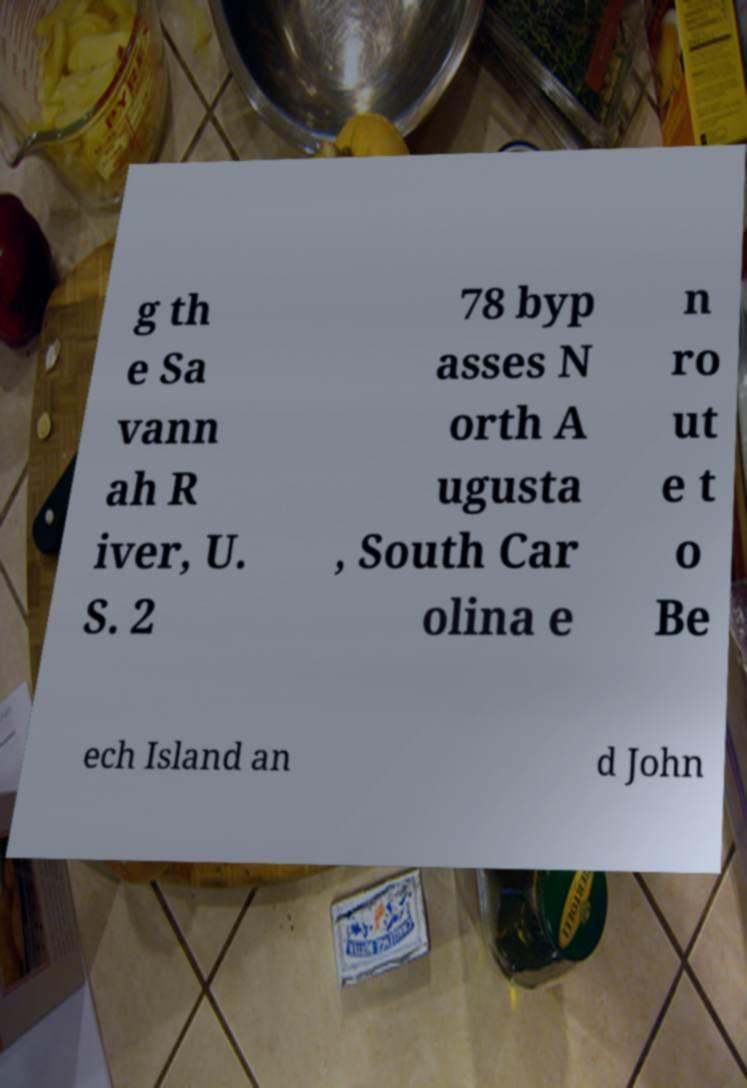Could you assist in decoding the text presented in this image and type it out clearly? g th e Sa vann ah R iver, U. S. 2 78 byp asses N orth A ugusta , South Car olina e n ro ut e t o Be ech Island an d John 